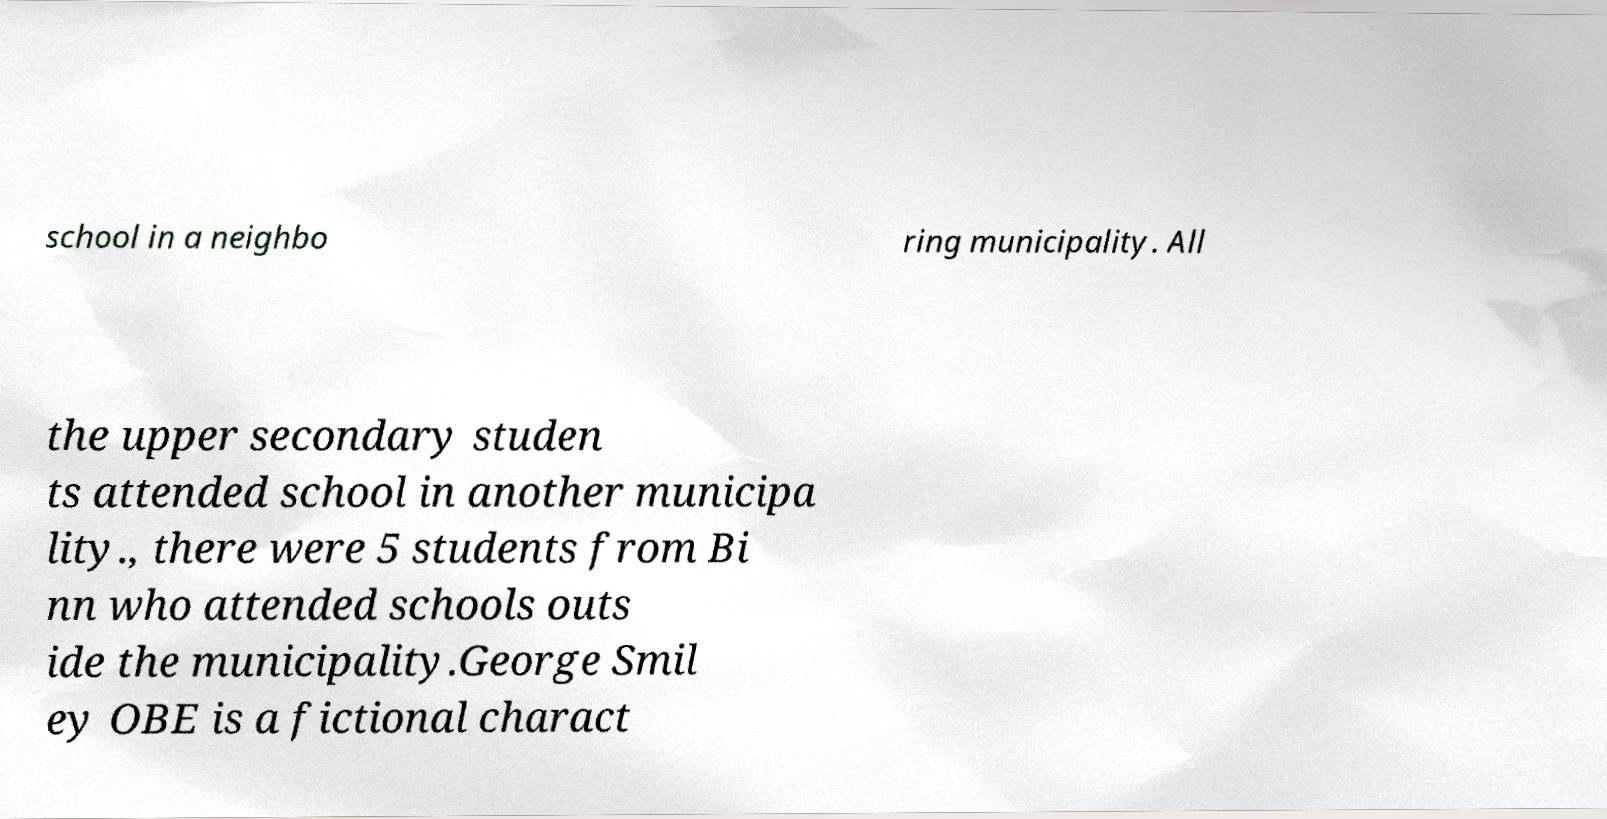For documentation purposes, I need the text within this image transcribed. Could you provide that? school in a neighbo ring municipality. All the upper secondary studen ts attended school in another municipa lity., there were 5 students from Bi nn who attended schools outs ide the municipality.George Smil ey OBE is a fictional charact 